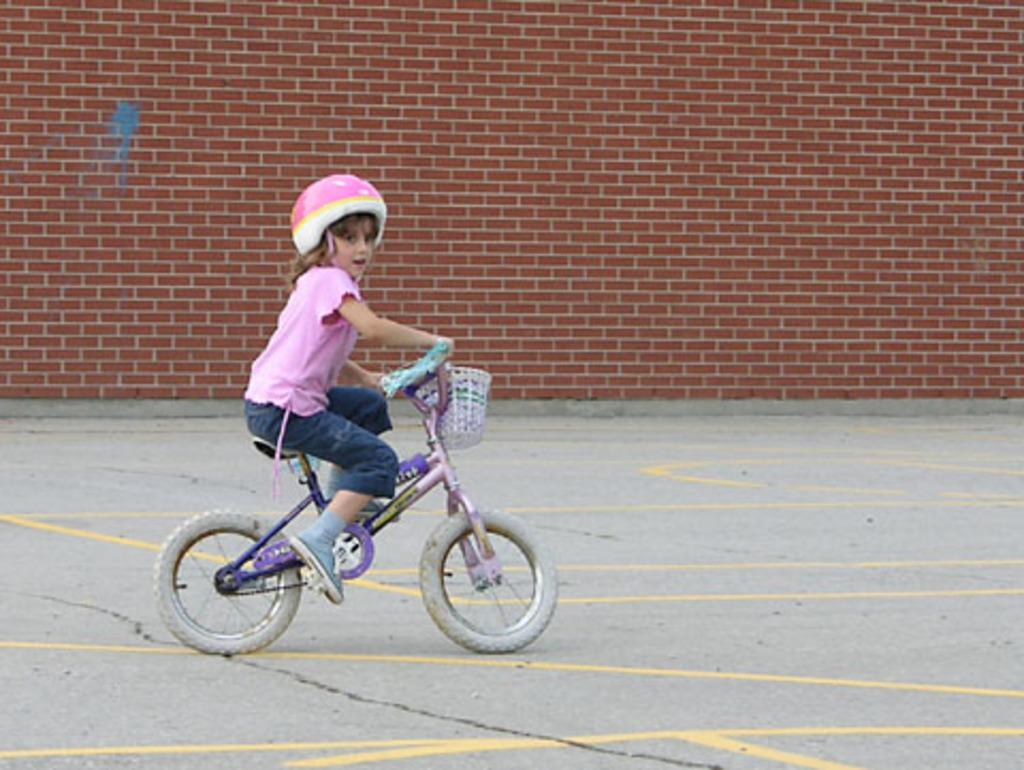Please provide a concise description of this image. In this picture we can see a girl wearing a helmet on her head and sitting on a bicycle. This bicycle is on the path. We can see a brick wall in the background. 